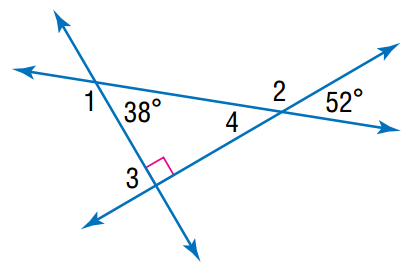Answer the mathemtical geometry problem and directly provide the correct option letter.
Question: Find the angle measure of \angle 1.
Choices: A: 128 B: 132 C: 142 D: 152 C 